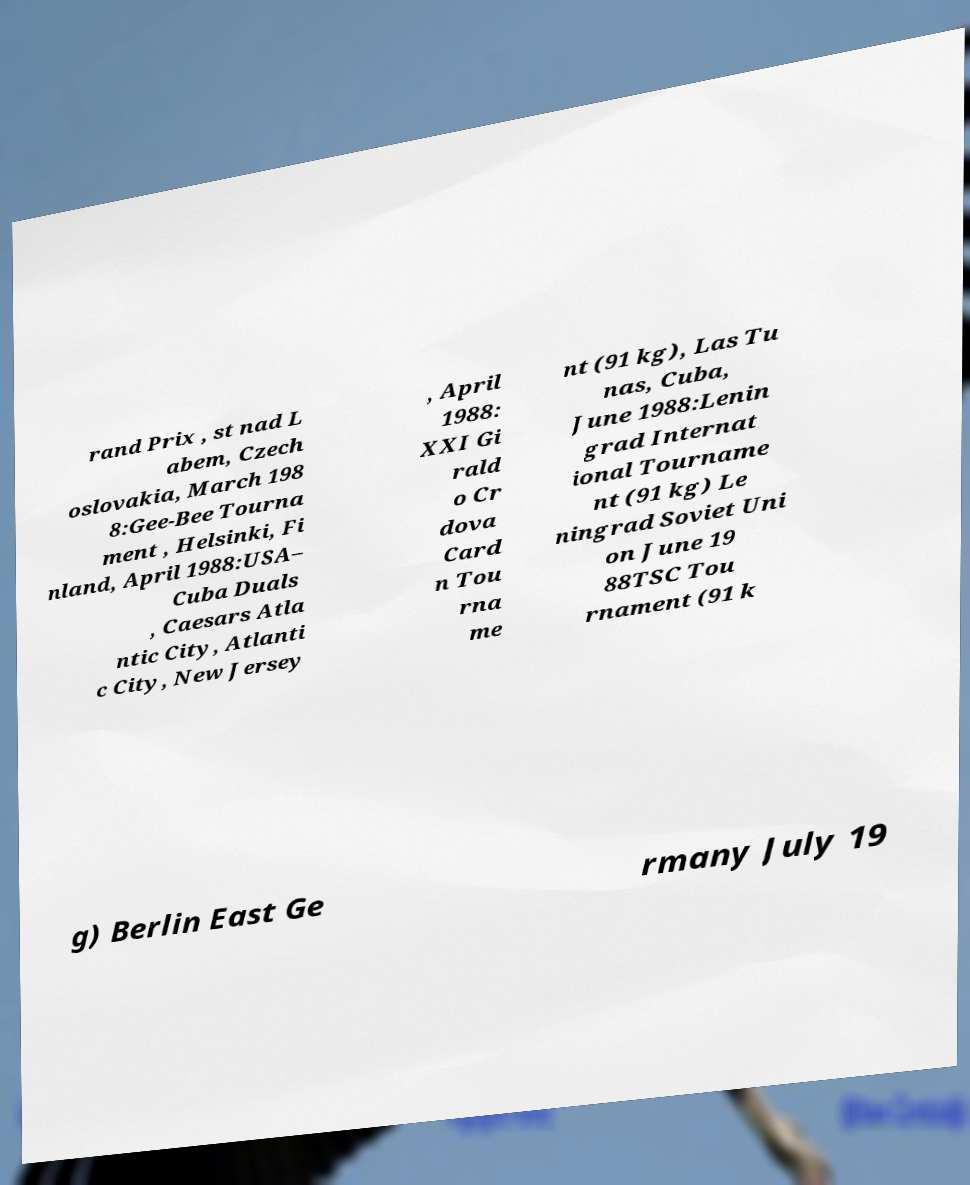Could you assist in decoding the text presented in this image and type it out clearly? rand Prix , st nad L abem, Czech oslovakia, March 198 8:Gee-Bee Tourna ment , Helsinki, Fi nland, April 1988:USA– Cuba Duals , Caesars Atla ntic City, Atlanti c City, New Jersey , April 1988: XXI Gi rald o Cr dova Card n Tou rna me nt (91 kg), Las Tu nas, Cuba, June 1988:Lenin grad Internat ional Tourname nt (91 kg) Le ningrad Soviet Uni on June 19 88TSC Tou rnament (91 k g) Berlin East Ge rmany July 19 